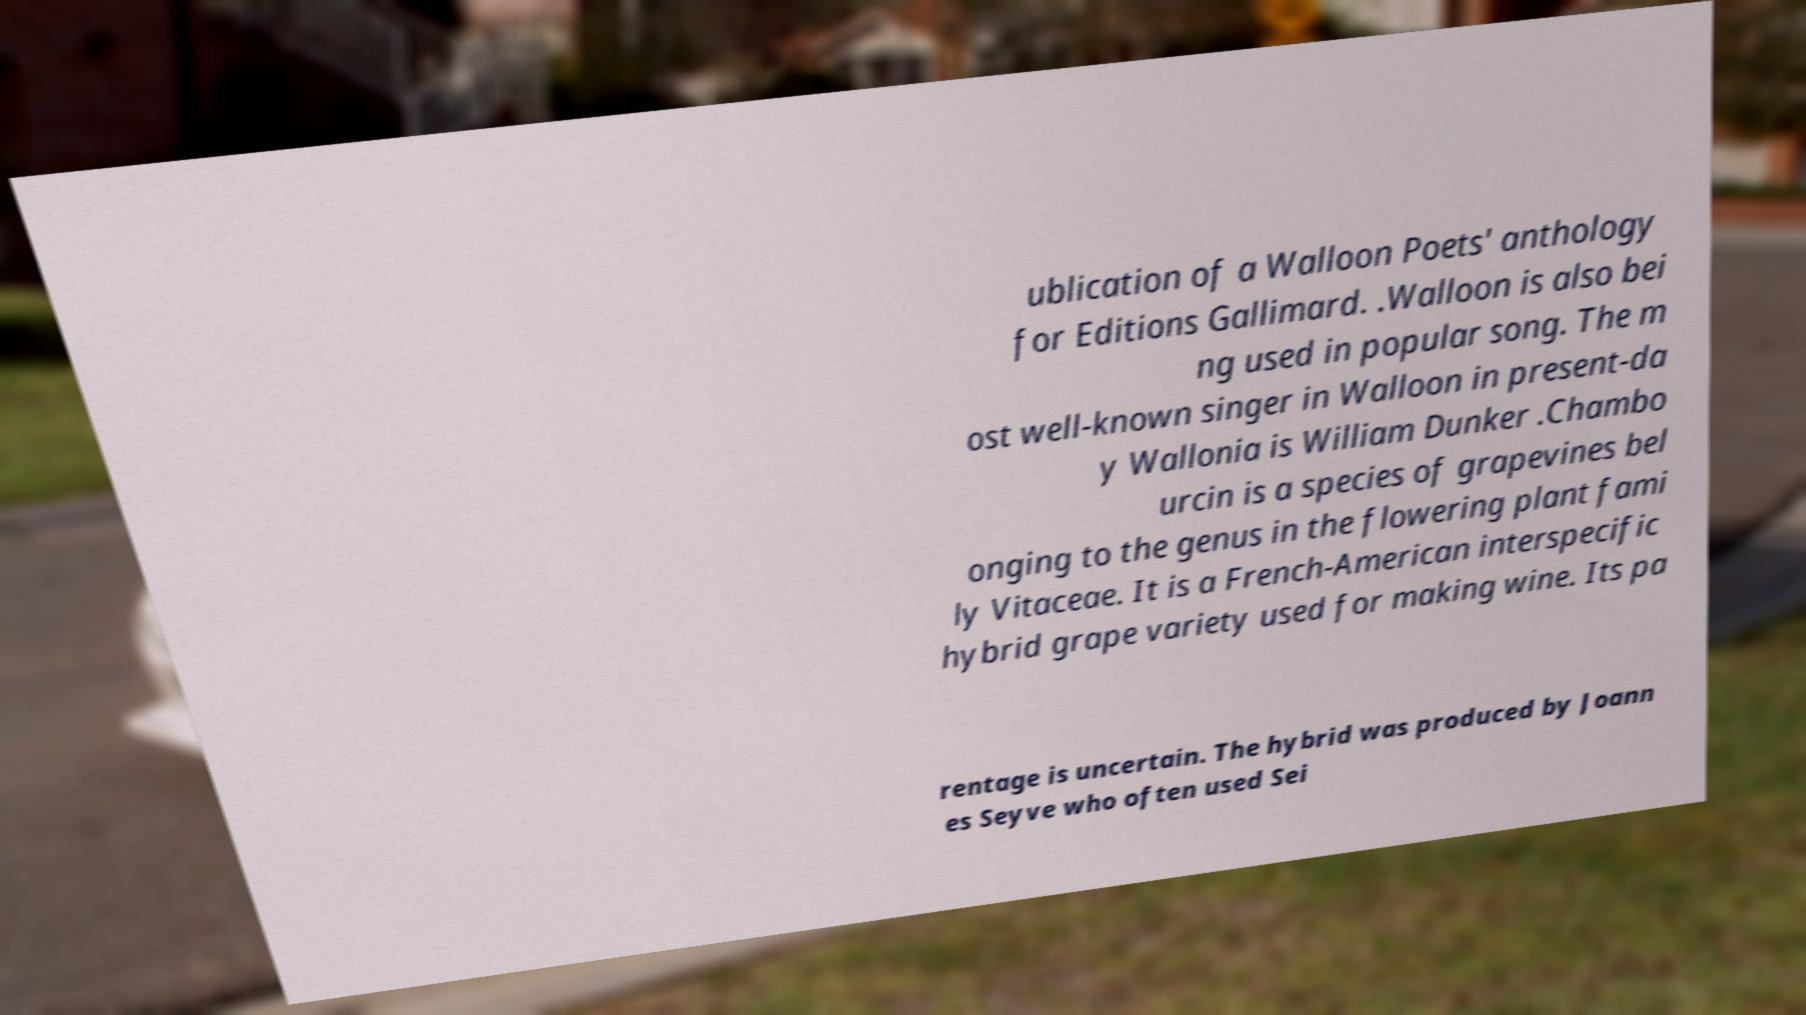Could you assist in decoding the text presented in this image and type it out clearly? ublication of a Walloon Poets' anthology for Editions Gallimard. .Walloon is also bei ng used in popular song. The m ost well-known singer in Walloon in present-da y Wallonia is William Dunker .Chambo urcin is a species of grapevines bel onging to the genus in the flowering plant fami ly Vitaceae. It is a French-American interspecific hybrid grape variety used for making wine. Its pa rentage is uncertain. The hybrid was produced by Joann es Seyve who often used Sei 